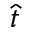Convert formula to latex. <formula><loc_0><loc_0><loc_500><loc_500>\widehat { t }</formula> 